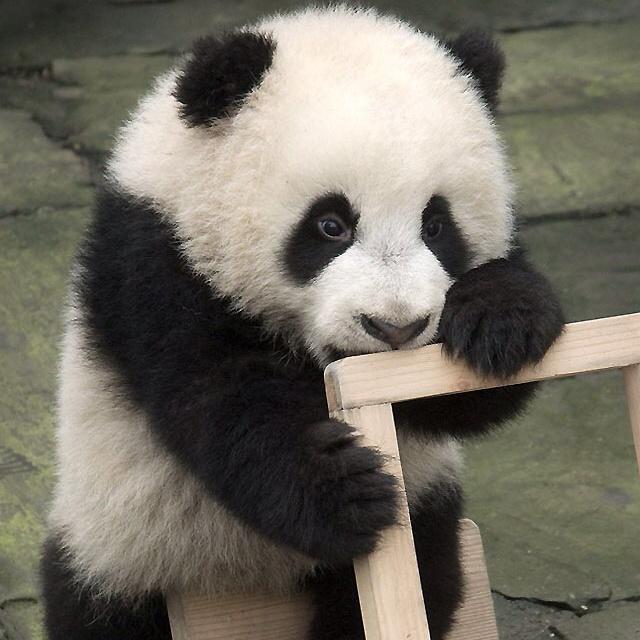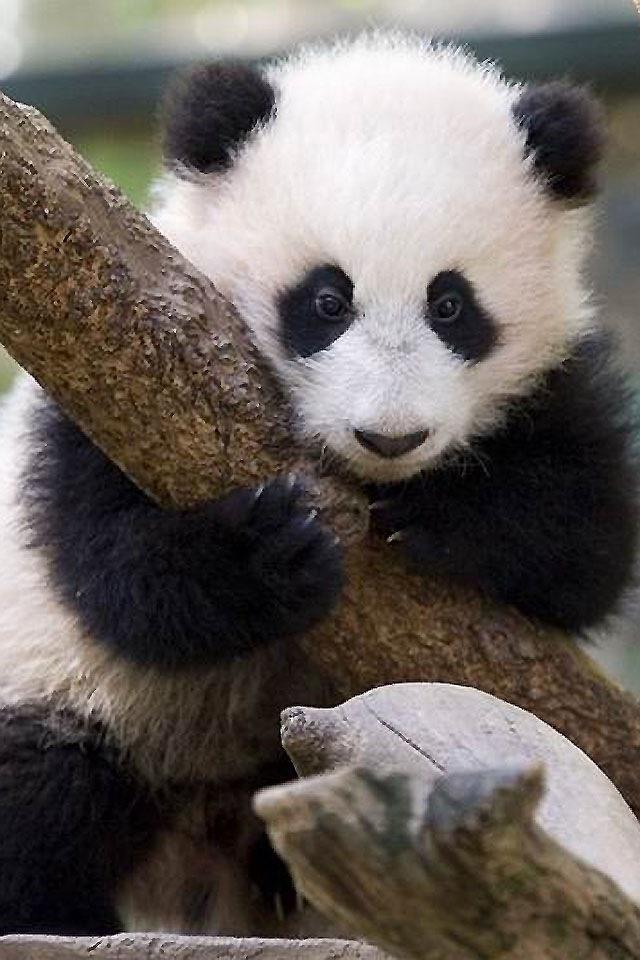The first image is the image on the left, the second image is the image on the right. Analyze the images presented: Is the assertion "Two panda faces can be seen, one on top of the other, in one image." valid? Answer yes or no. No. The first image is the image on the left, the second image is the image on the right. For the images displayed, is the sentence "A panda has its head on the floor in the right image." factually correct? Answer yes or no. No. 